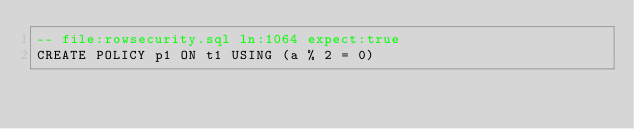<code> <loc_0><loc_0><loc_500><loc_500><_SQL_>-- file:rowsecurity.sql ln:1064 expect:true
CREATE POLICY p1 ON t1 USING (a % 2 = 0)
</code> 